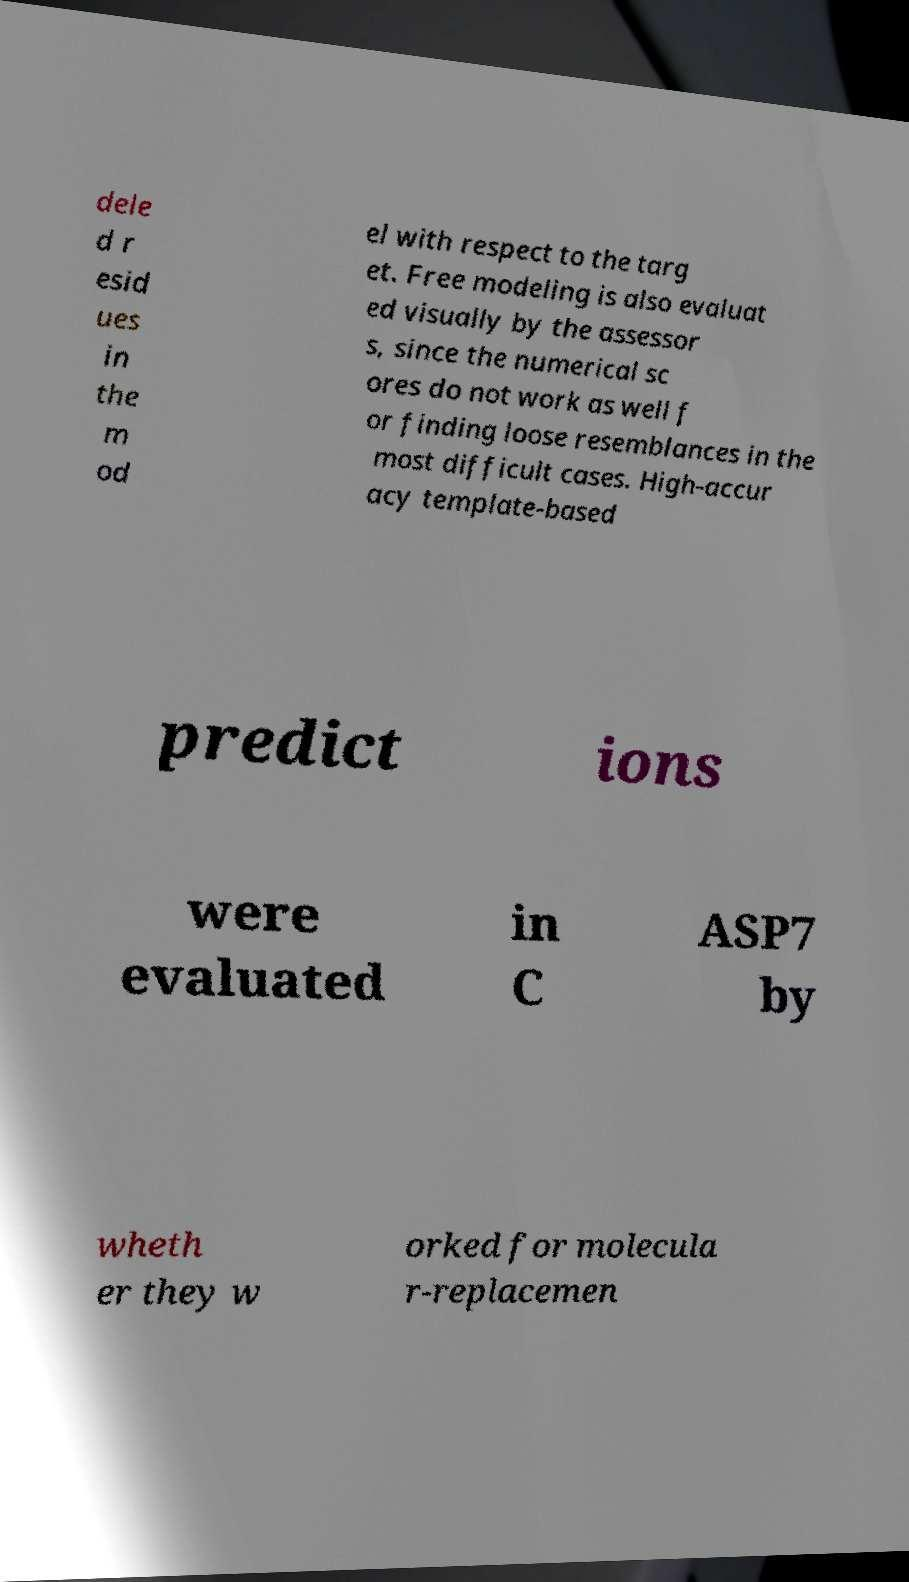For documentation purposes, I need the text within this image transcribed. Could you provide that? dele d r esid ues in the m od el with respect to the targ et. Free modeling is also evaluat ed visually by the assessor s, since the numerical sc ores do not work as well f or finding loose resemblances in the most difficult cases. High-accur acy template-based predict ions were evaluated in C ASP7 by wheth er they w orked for molecula r-replacemen 